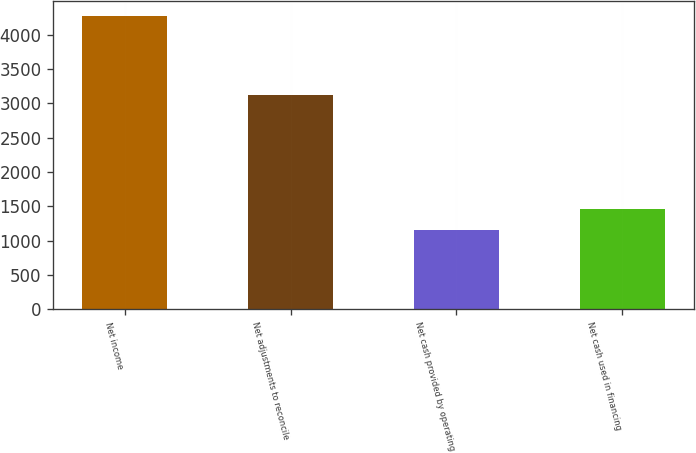Convert chart. <chart><loc_0><loc_0><loc_500><loc_500><bar_chart><fcel>Net income<fcel>Net adjustments to reconcile<fcel>Net cash provided by operating<fcel>Net cash used in financing<nl><fcel>4279<fcel>3124<fcel>1155<fcel>1467.4<nl></chart> 